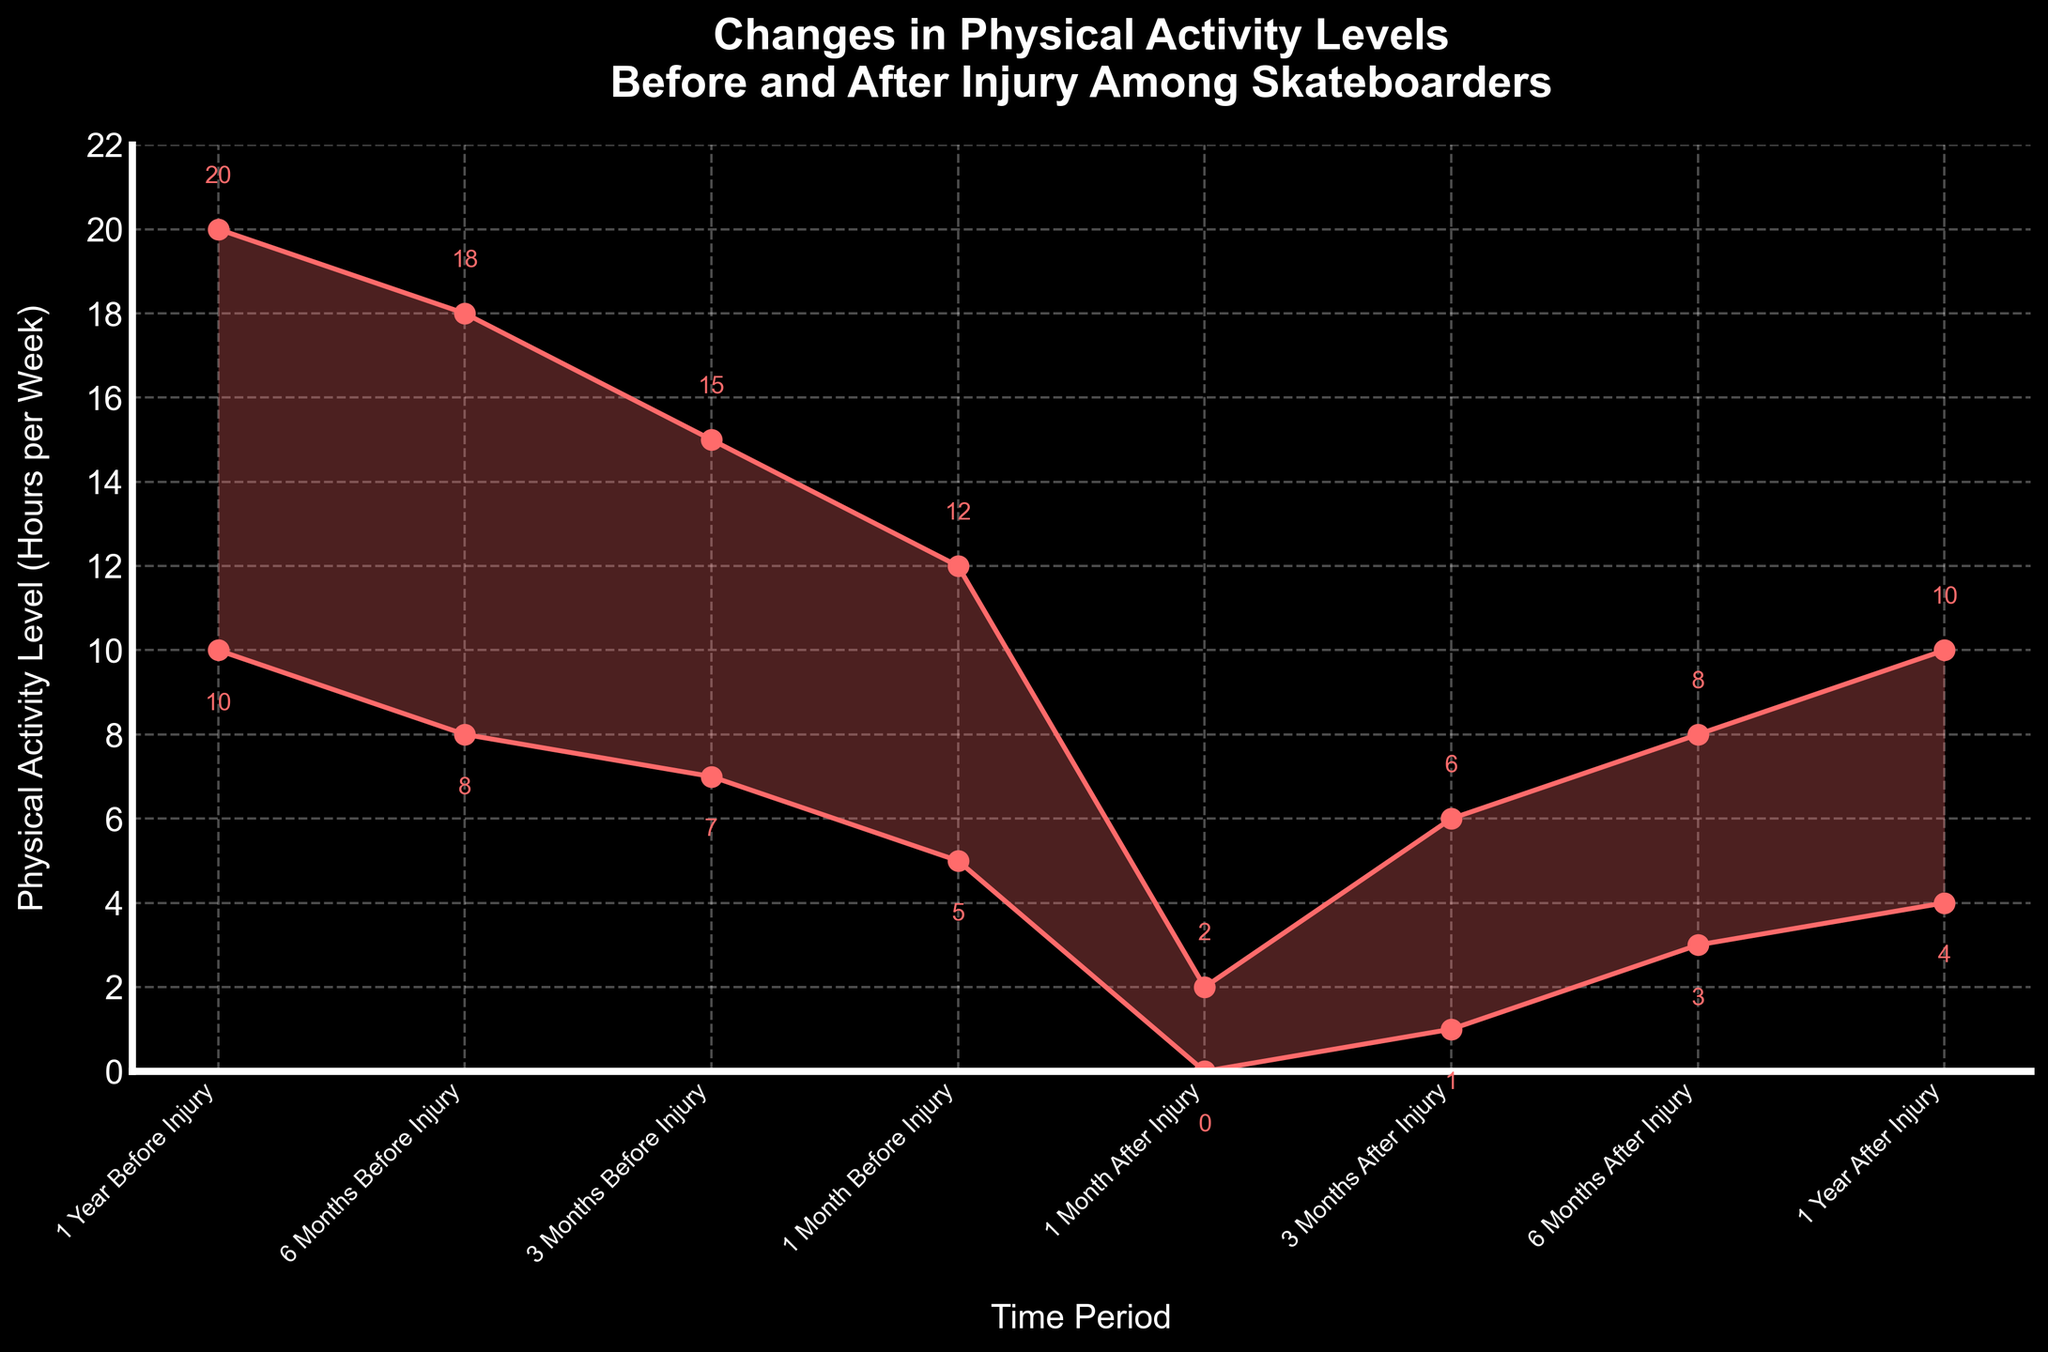What is the title of the plot? The title is present at the top of the plot and reads "Changes in Physical Activity Levels Before and After Injury Among Skateboarders."
Answer: Changes in Physical Activity Levels Before and After Injury Among Skateboarders What is the physical activity range 1 year before injury? The physical activity level range is represented by the filled area between the two lines for "1 Year Before Injury." Checking the values, the minimum is 10, and the maximum is 20 hours per week.
Answer: 10 to 20 hours per week Which time period has the lowest maximum physical activity level? By examining the maximum values across all time periods, the lowest appears to be "1 Month After Injury," with a maximum of 2 hours per week.
Answer: 1 Month After Injury At which time period did the minimum physical activity level start increasing again after the injury? After the injury, the minimum physical activity level begins to increase from "1 Month After Injury" to "3 Months After Injury," where it rises from 0 to 1 hour per week.
Answer: 3 Months After Injury What is the difference in maximum physical activity levels between 1 year before injury and 1 year after injury? The maximum physical activity level 1 year before injury is 20 hours per week, and 1 year after injury, it is 10 hours per week. The difference is calculated as 20 - 10 = 10 hours per week.
Answer: 10 hours per week How does the physical activity range change from 3 months before injury to 1 month before injury? The range 3 months before injury is between 7 and 15 hours per week. By 1 month before injury, it decreases to between 5 and 12 hours per week. Both minimum and maximum values have decreased by 2 and 3 hours respectively.
Answer: Decreases by 2 to 3 hours What is the total change in minimum physical activity level from 1 month after injury to 1 year after injury? The minimum physical activity level 1 month after injury is 0 hours per week, and 1 year after injury it is 4 hours per week. The total increase is calculated as 4 - 0 = 4 hours per week.
Answer: 4 hours per week Based on the plot, for which period is there the largest difference between the minimum and maximum physical activity levels? The difference is calculated by subtracting the minimum from the maximum for each time period. "1 Year Before Injury" has the largest difference with 20 - 10 = 10 hours per week.
Answer: 1 Year Before Injury 